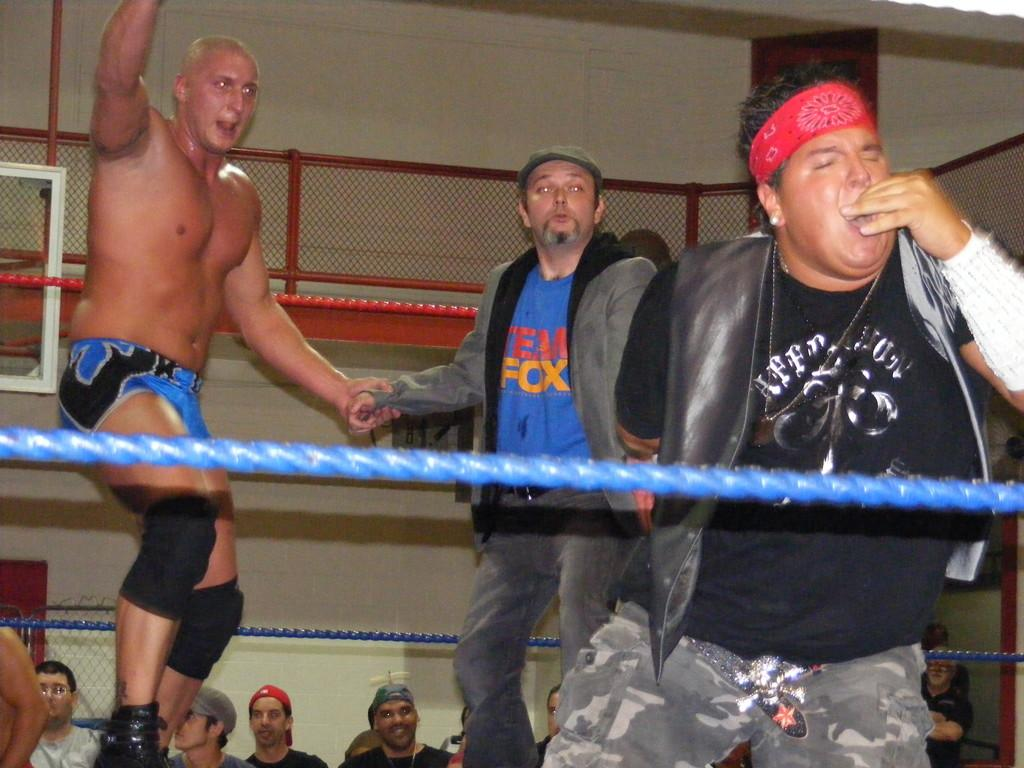<image>
Create a compact narrative representing the image presented. A man in the middle of a boxing ring with the words FOX on his shirt 